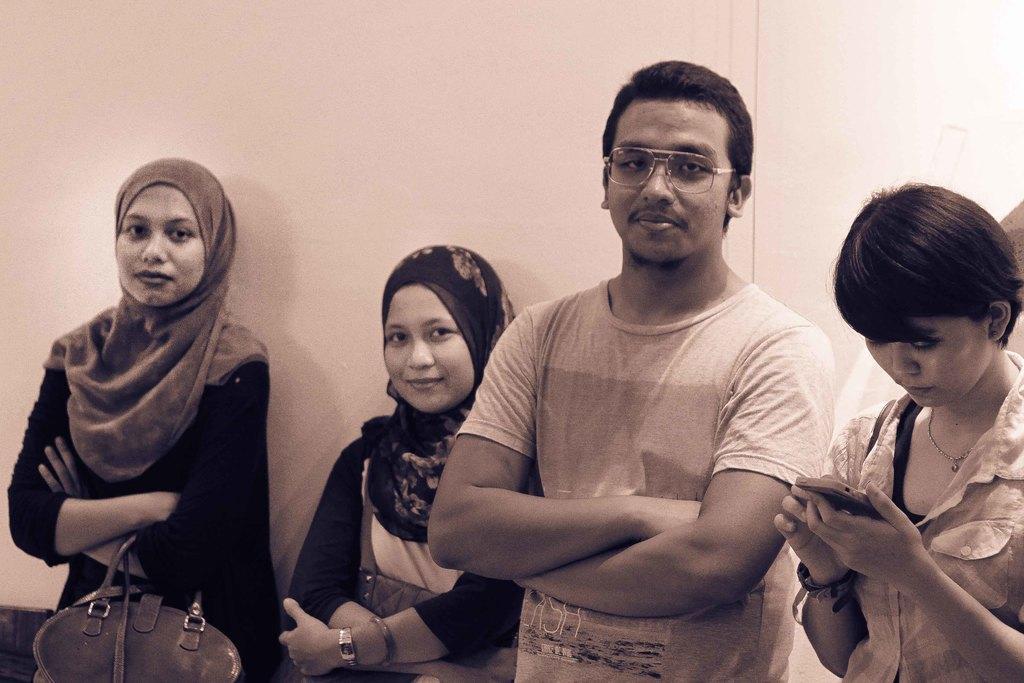In one or two sentences, can you explain what this image depicts? This looks like a black and white image. There are three women and one man standing. This is a handbag holded by the women. I can see another woman holding and using mobile phone. This looks like a wall. 